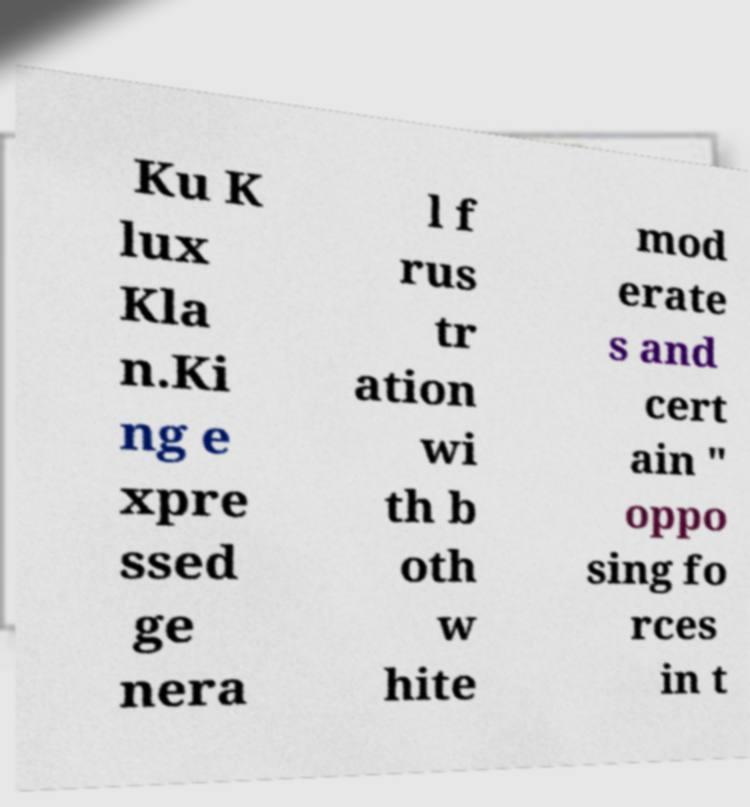Could you assist in decoding the text presented in this image and type it out clearly? Ku K lux Kla n.Ki ng e xpre ssed ge nera l f rus tr ation wi th b oth w hite mod erate s and cert ain " oppo sing fo rces in t 